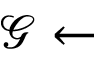Convert formula to latex. <formula><loc_0><loc_0><loc_500><loc_500>\mathcal { G } \leftarrow</formula> 